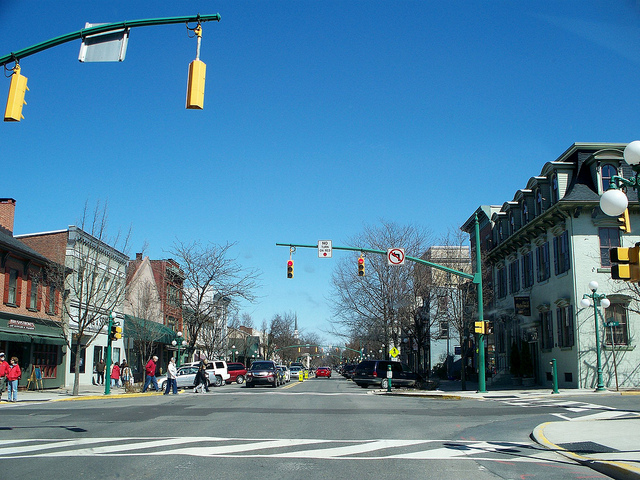<image>What is the closest restaurant? It is unknown what the closest restaurant is. The options provided include 'pub', 'McDonald's', 'Domino's', and 'O'Connell's'. What is the name on the building? It is unknown what the name on the building is. However, it could possibly be a shop, store, or 'shellington'. What is the name on the building? It is unknown what is the name on the building. It is also possible that there is no name on the building. What is the closest restaurant? It is ambiguous what is the closest restaurant. It can be 'pub', "mcdonald's", "domino's", "o'connell's" or 'pointed roof building'. 